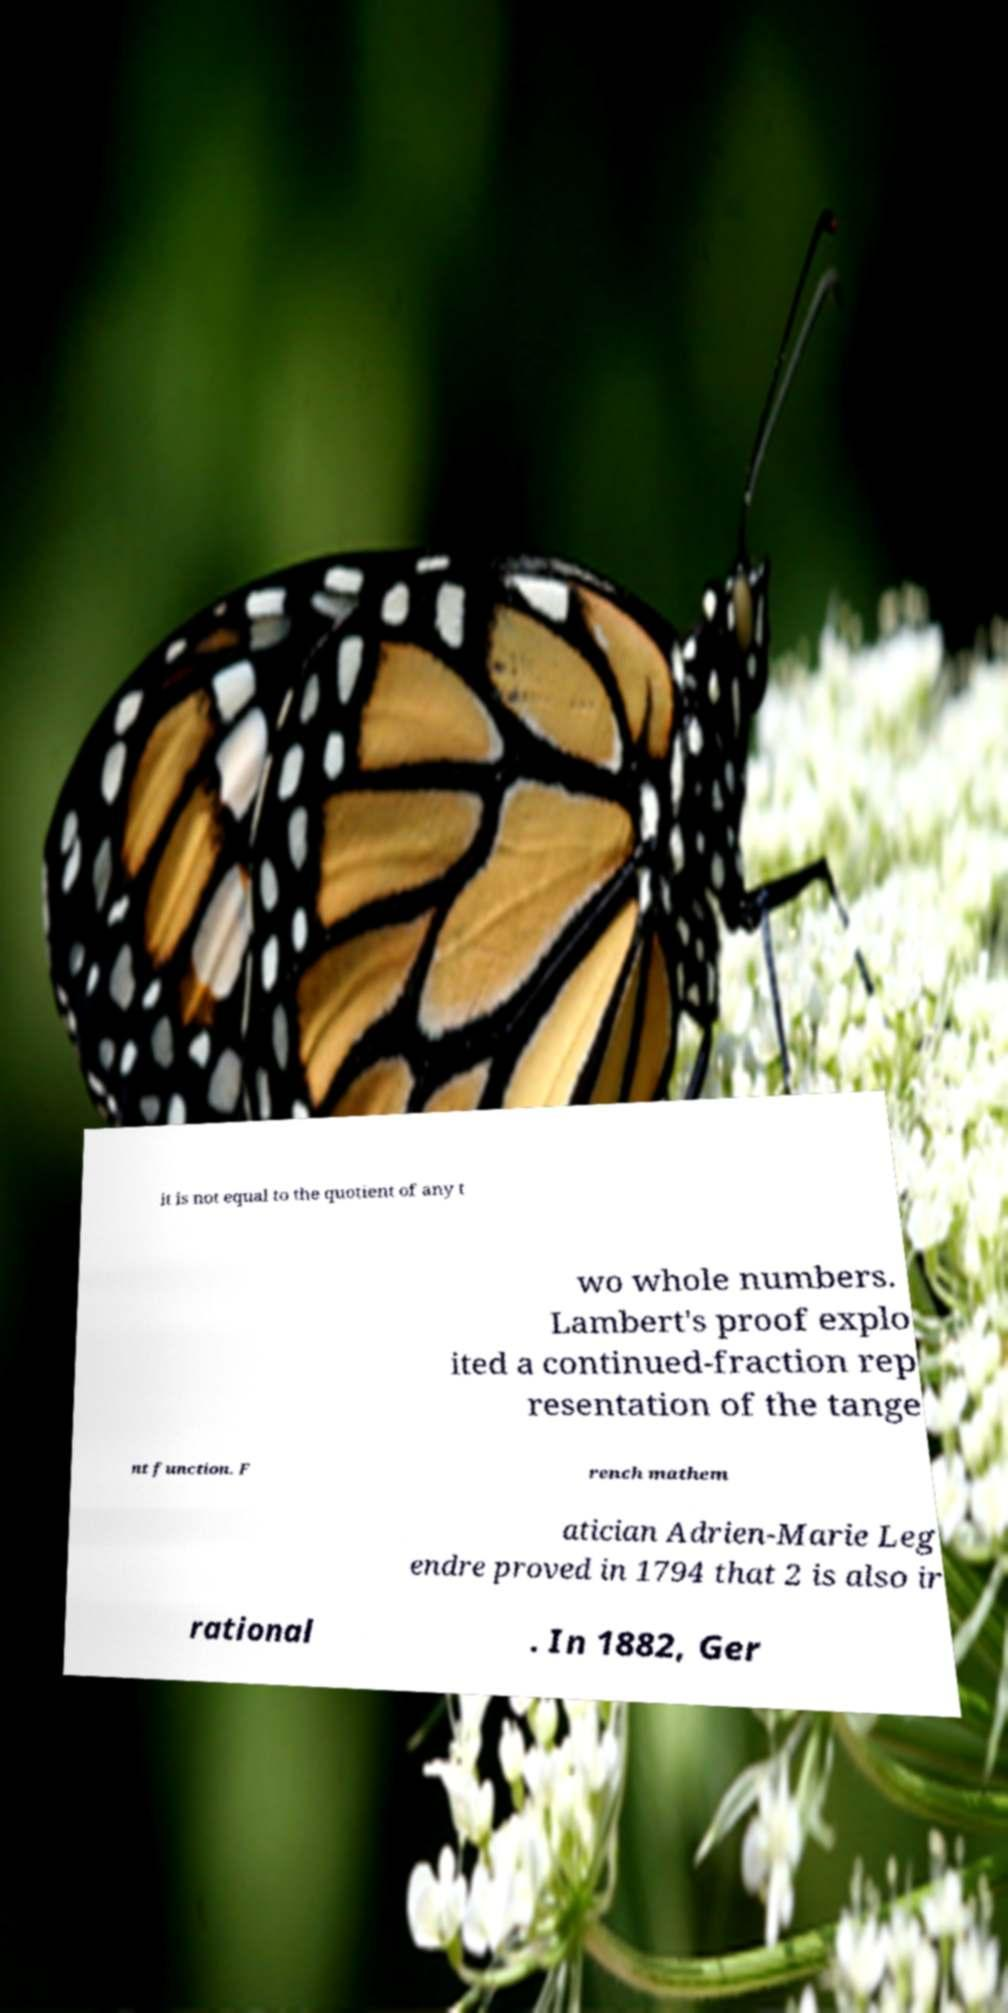For documentation purposes, I need the text within this image transcribed. Could you provide that? it is not equal to the quotient of any t wo whole numbers. Lambert's proof explo ited a continued-fraction rep resentation of the tange nt function. F rench mathem atician Adrien-Marie Leg endre proved in 1794 that 2 is also ir rational . In 1882, Ger 